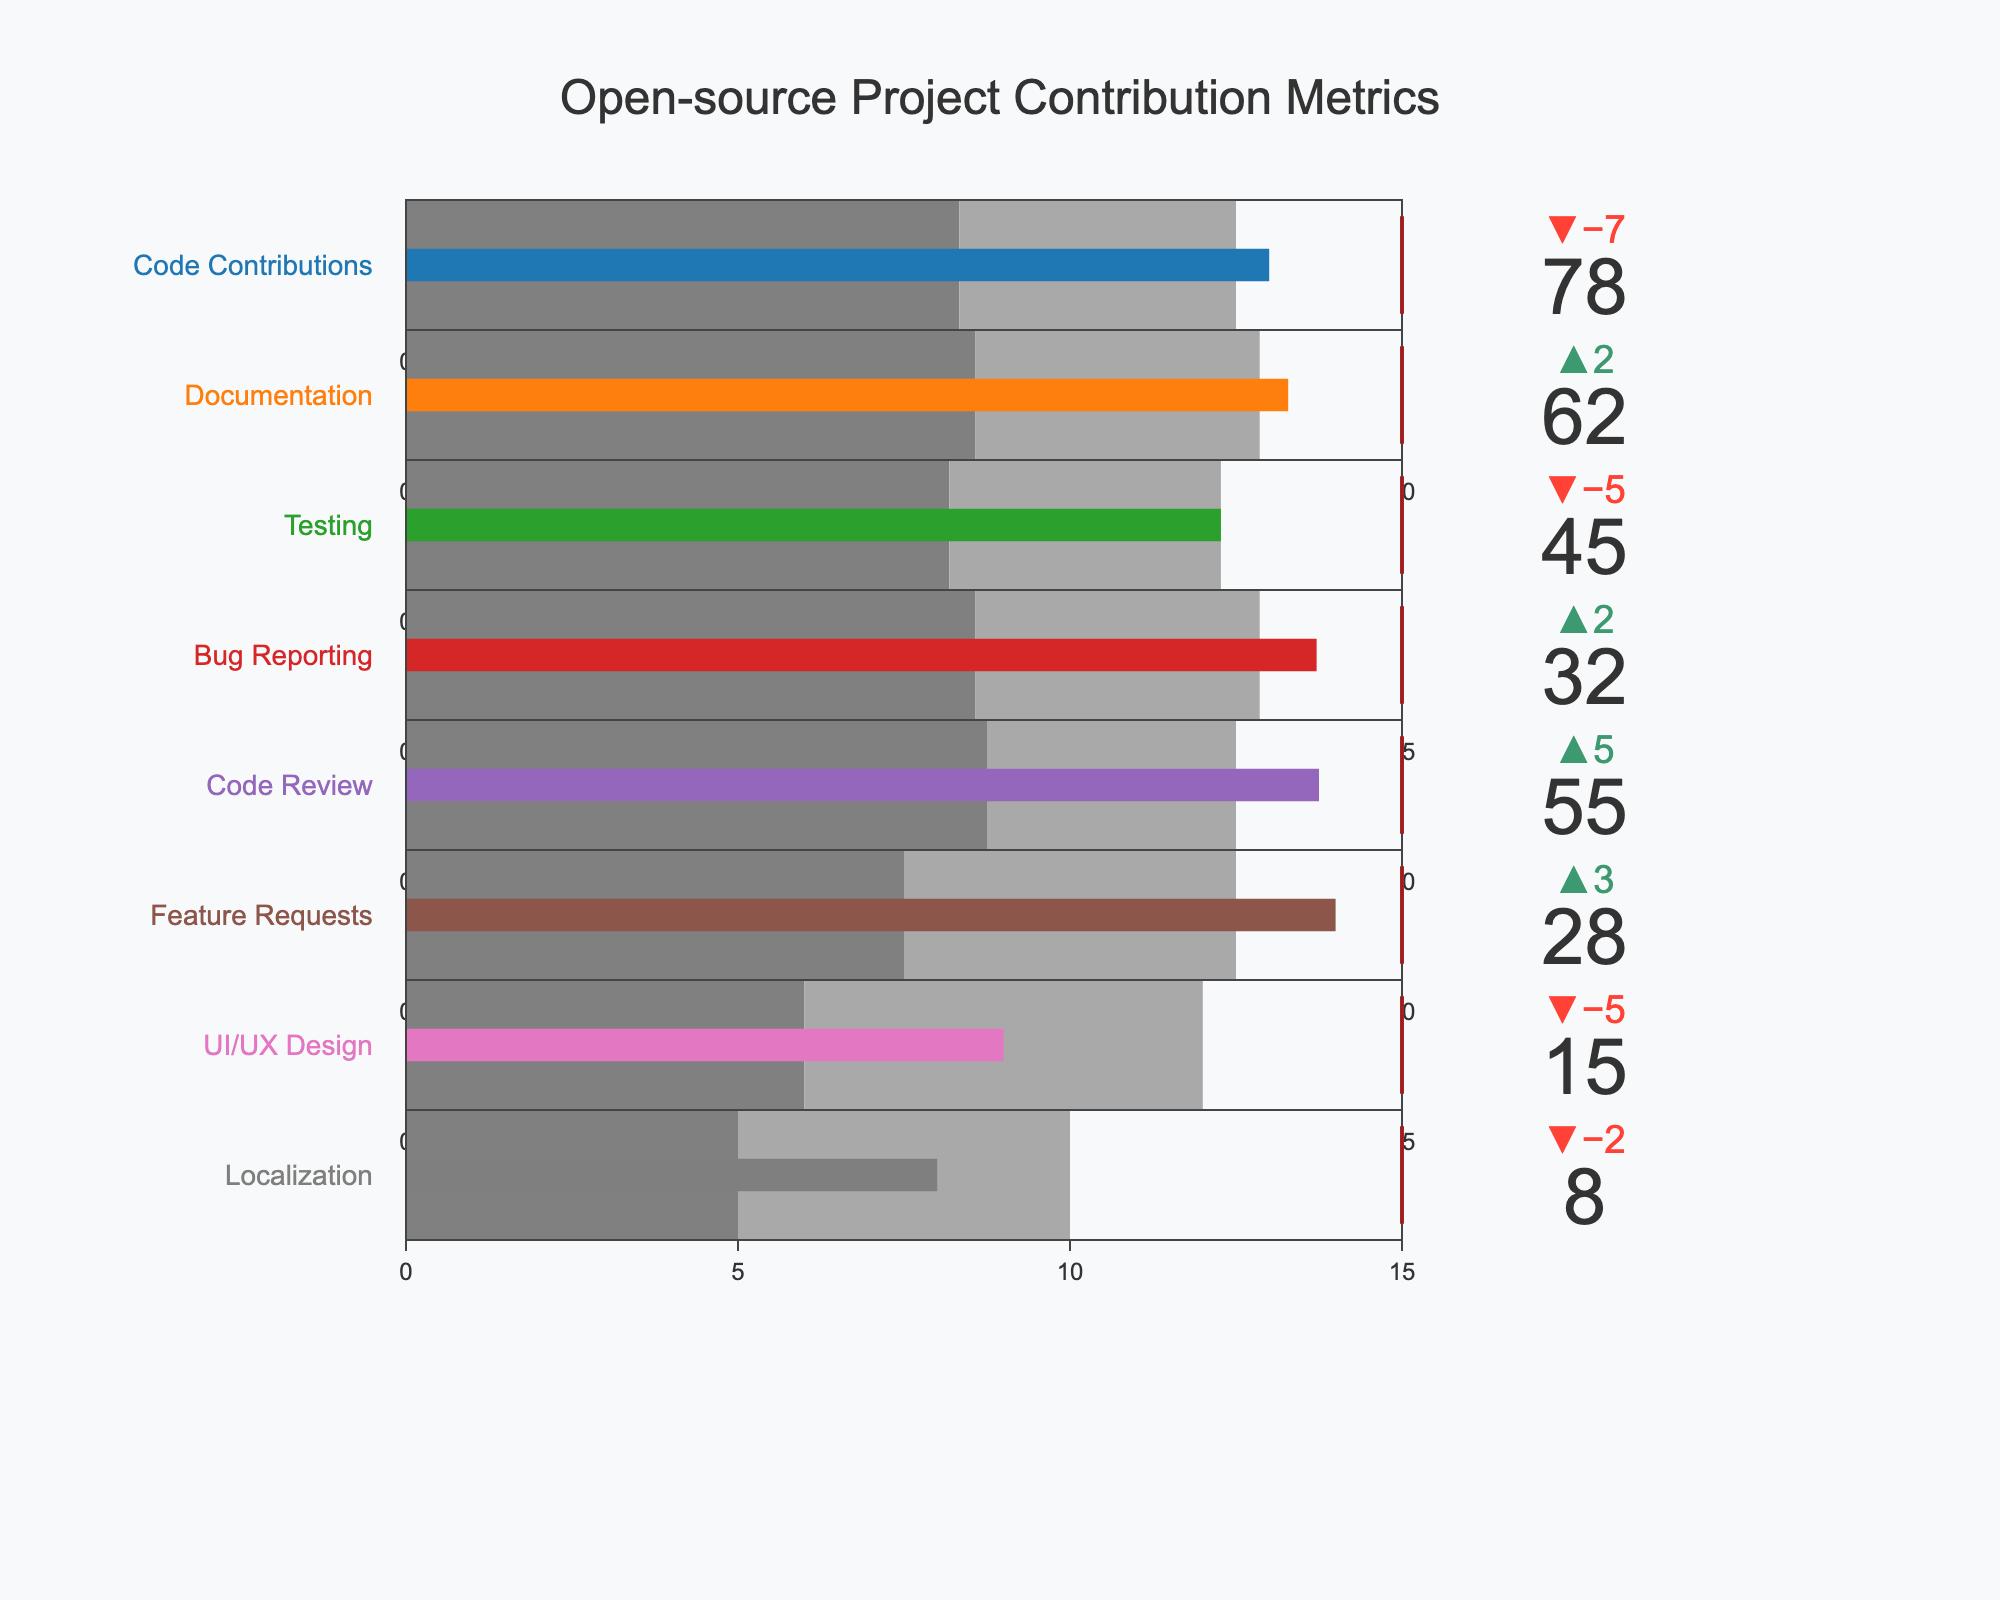what is the title of the figure? The title typically appears at the top of the figure and is usually written in a larger or different font to make it stand out. In this case, it is positioned at the center and reads "Open-source Project Contribution Metrics".
Answer: Open-source Project Contribution Metrics how many roles are represented in the bullet chart? Each role corresponds to one bullet indicator on the chart. By counting the number of bullet indicators, we can determine the number of roles. There are 8 roles listed.
Answer: 8 what is the actual value for documentation contributions? The actual value for documentation contributions is the numeric value shown within the bullet indicator for that role. It is displayed as 62.
Answer: 62 what is the target value for bug reporting contributions? The target value is represented by a red threshold line on each bullet chart. For Bug Reporting, this value is 35, as indicated by the target marker.
Answer: 35 which role has the highest actual value? The role with the highest actual value is determined by comparing the 'Actual' values for each role. Code Contributions have the highest actual value at 78.
Answer: Code Contributions what is the difference between the actual and comparative values for code review contributions? The actual value for Code Review contributions is 55, and the comparative value is 50. The difference is calculated as 55 - 50 = 5.
Answer: 5 is the actual value for localization contributions less than or equal to its comparative value? The actual value for Localization contributions is 8, and the comparative value is 10. Since 8 is indeed less than 10, the actual value is less than or equal to the comparative value.
Answer: Yes what role has an actual value closest to its target value? To find the role with an actual value closest to its target, calculate the difference between the actual and target for each role. The smallest difference is for Code Contributions (90 - 78 = 12).
Answer: Code Contributions how many roles have their actual values greater than their comparative values? Compare the actual values to the comparative values for each role. The roles where Actual > Comparative are Code Contributions, Documentation, Code Review, and Bug Reporting, which amounts to 4 roles.
Answer: 4 what is the sum of the actual values for testing contributions and ui/ux design contributions? Add the actual values for the roles Testing and UI/UX Design. Testing has 45 and UI/UX Design has 15. So, 45 + 15 = 60.
Answer: 60 